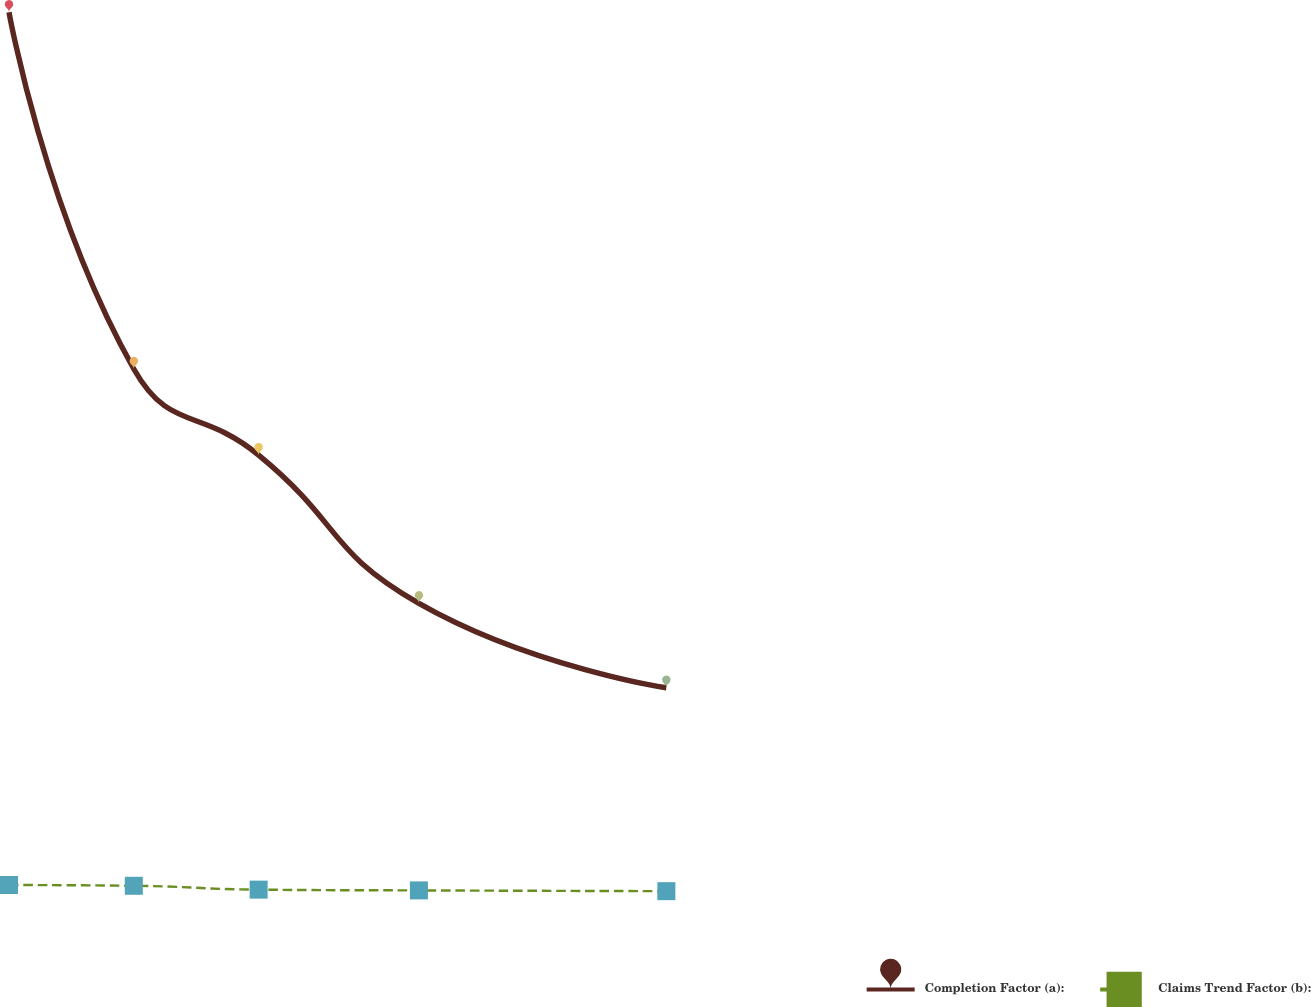<chart> <loc_0><loc_0><loc_500><loc_500><line_chart><ecel><fcel>Completion Factor (a):<fcel>Claims Trend Factor (b):<nl><fcel>9.7<fcel>368.67<fcel>4.99<nl><fcel>22.79<fcel>220.01<fcel>4.67<nl><fcel>35.88<fcel>184.13<fcel>3.07<nl><fcel>52.69<fcel>122.38<fcel>2.75<nl><fcel>78.64<fcel>87.2<fcel>2.43<nl><fcel>130.85<fcel>52.02<fcel>2.07<nl><fcel>143.94<fcel>16.84<fcel>1.49<nl></chart> 